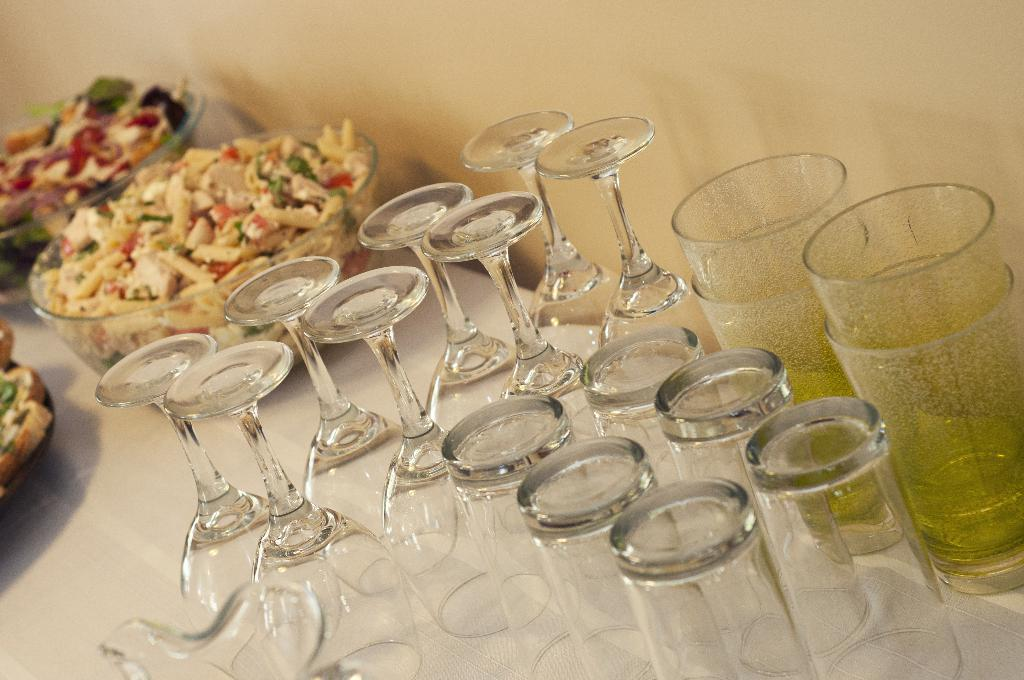What objects in the image are typically used for drinking? There are glasses in the image that are typically used for drinking. What is in the bowl that is visible in the image? There is a bowl with a food item in the image. What can be seen in the background of the image? There is a wall visible in the background of the image. What type of soap is being used to clean the hand in the image? There is no hand or soap present in the image. 